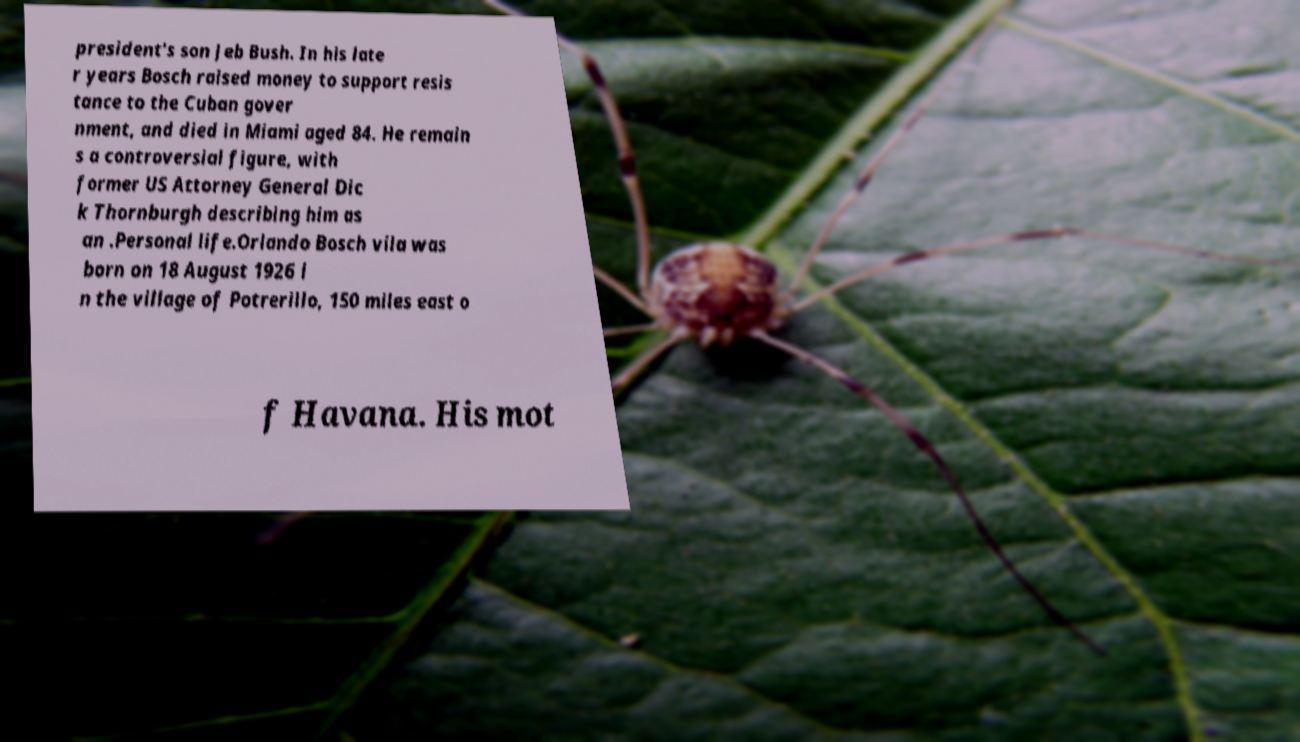Can you accurately transcribe the text from the provided image for me? president's son Jeb Bush. In his late r years Bosch raised money to support resis tance to the Cuban gover nment, and died in Miami aged 84. He remain s a controversial figure, with former US Attorney General Dic k Thornburgh describing him as an .Personal life.Orlando Bosch vila was born on 18 August 1926 i n the village of Potrerillo, 150 miles east o f Havana. His mot 